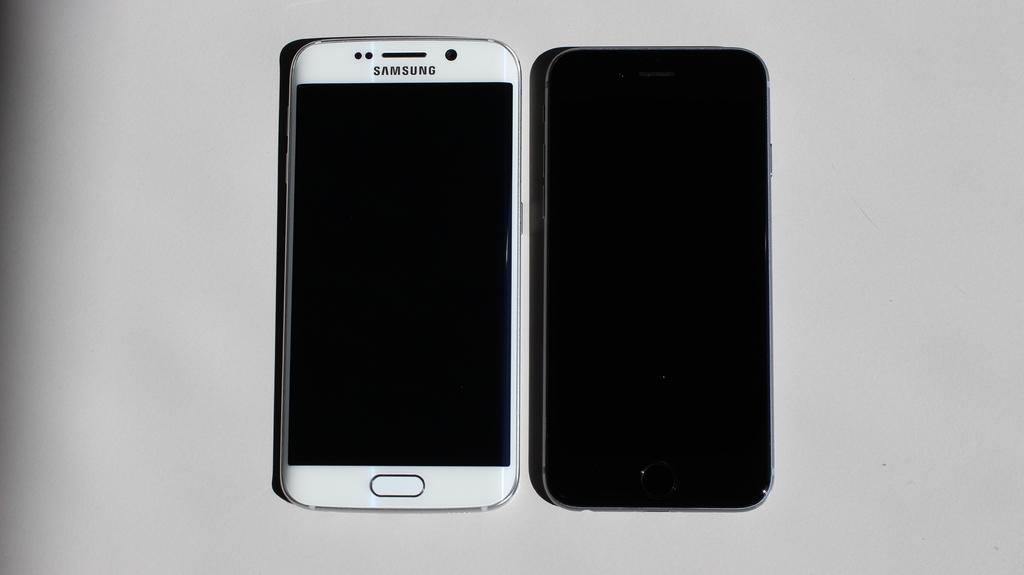What brand of phone is this?
Ensure brevity in your answer.  Samsung. 